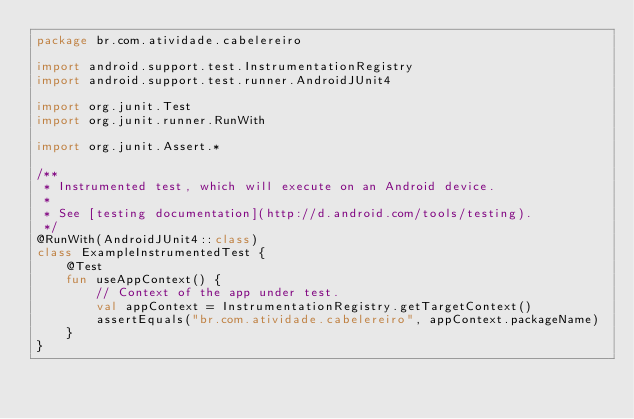<code> <loc_0><loc_0><loc_500><loc_500><_Kotlin_>package br.com.atividade.cabelereiro

import android.support.test.InstrumentationRegistry
import android.support.test.runner.AndroidJUnit4

import org.junit.Test
import org.junit.runner.RunWith

import org.junit.Assert.*

/**
 * Instrumented test, which will execute on an Android device.
 *
 * See [testing documentation](http://d.android.com/tools/testing).
 */
@RunWith(AndroidJUnit4::class)
class ExampleInstrumentedTest {
    @Test
    fun useAppContext() {
        // Context of the app under test.
        val appContext = InstrumentationRegistry.getTargetContext()
        assertEquals("br.com.atividade.cabelereiro", appContext.packageName)
    }
}
</code> 